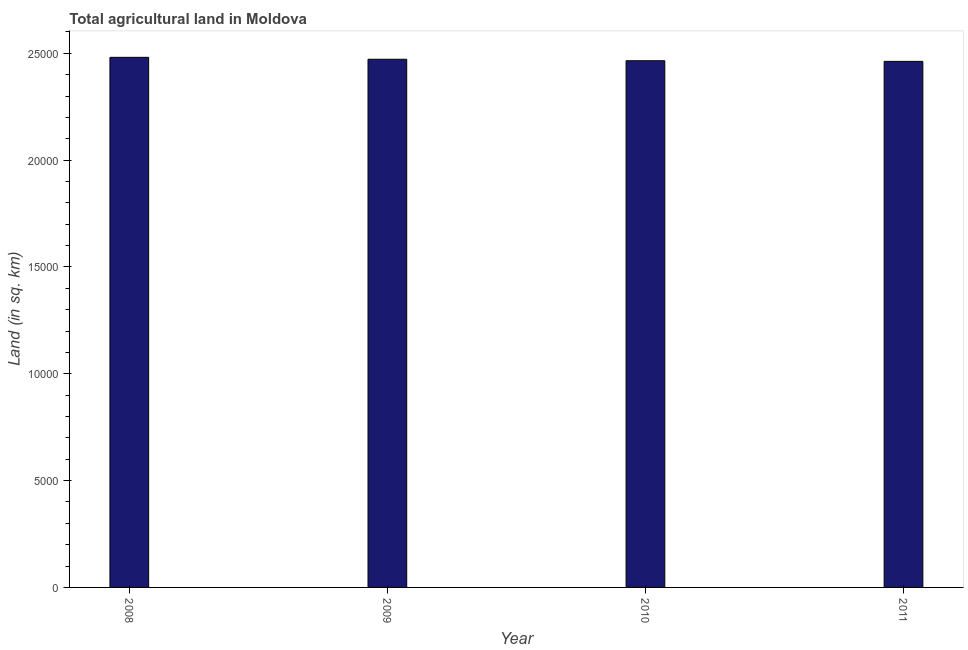Does the graph contain grids?
Your answer should be compact. No. What is the title of the graph?
Offer a very short reply. Total agricultural land in Moldova. What is the label or title of the X-axis?
Provide a short and direct response. Year. What is the label or title of the Y-axis?
Your response must be concise. Land (in sq. km). What is the agricultural land in 2009?
Your response must be concise. 2.47e+04. Across all years, what is the maximum agricultural land?
Your response must be concise. 2.48e+04. Across all years, what is the minimum agricultural land?
Offer a terse response. 2.46e+04. In which year was the agricultural land maximum?
Give a very brief answer. 2008. What is the sum of the agricultural land?
Your answer should be compact. 9.88e+04. What is the difference between the agricultural land in 2009 and 2011?
Keep it short and to the point. 100. What is the average agricultural land per year?
Offer a terse response. 2.47e+04. What is the median agricultural land?
Keep it short and to the point. 2.47e+04. In how many years, is the agricultural land greater than 21000 sq. km?
Keep it short and to the point. 4. Is the difference between the agricultural land in 2009 and 2011 greater than the difference between any two years?
Your response must be concise. No. Is the sum of the agricultural land in 2009 and 2011 greater than the maximum agricultural land across all years?
Your answer should be very brief. Yes. What is the difference between the highest and the lowest agricultural land?
Offer a terse response. 190. In how many years, is the agricultural land greater than the average agricultural land taken over all years?
Give a very brief answer. 2. Are all the bars in the graph horizontal?
Give a very brief answer. No. What is the difference between two consecutive major ticks on the Y-axis?
Ensure brevity in your answer.  5000. What is the Land (in sq. km) in 2008?
Your answer should be very brief. 2.48e+04. What is the Land (in sq. km) in 2009?
Offer a very short reply. 2.47e+04. What is the Land (in sq. km) in 2010?
Provide a short and direct response. 2.46e+04. What is the Land (in sq. km) in 2011?
Ensure brevity in your answer.  2.46e+04. What is the difference between the Land (in sq. km) in 2008 and 2010?
Your response must be concise. 160. What is the difference between the Land (in sq. km) in 2008 and 2011?
Your response must be concise. 190. What is the difference between the Land (in sq. km) in 2010 and 2011?
Your answer should be very brief. 30. What is the ratio of the Land (in sq. km) in 2008 to that in 2011?
Your response must be concise. 1.01. What is the ratio of the Land (in sq. km) in 2010 to that in 2011?
Give a very brief answer. 1. 